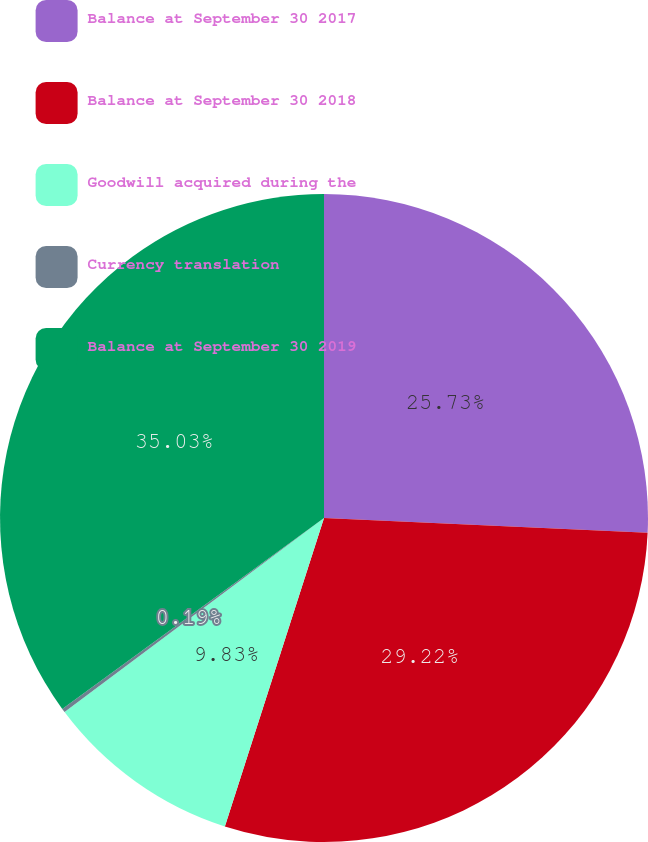<chart> <loc_0><loc_0><loc_500><loc_500><pie_chart><fcel>Balance at September 30 2017<fcel>Balance at September 30 2018<fcel>Goodwill acquired during the<fcel>Currency translation<fcel>Balance at September 30 2019<nl><fcel>25.73%<fcel>29.22%<fcel>9.83%<fcel>0.19%<fcel>35.03%<nl></chart> 